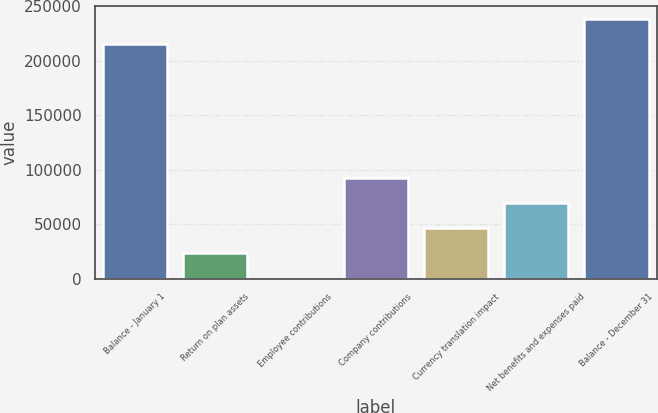Convert chart. <chart><loc_0><loc_0><loc_500><loc_500><bar_chart><fcel>Balance - January 1<fcel>Return on plan assets<fcel>Employee contributions<fcel>Company contributions<fcel>Currency translation impact<fcel>Net benefits and expenses paid<fcel>Balance - December 31<nl><fcel>215360<fcel>23363.5<fcel>312<fcel>92518<fcel>46415<fcel>69466.5<fcel>238412<nl></chart> 